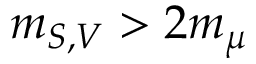<formula> <loc_0><loc_0><loc_500><loc_500>m _ { S , V } > 2 m _ { \mu }</formula> 